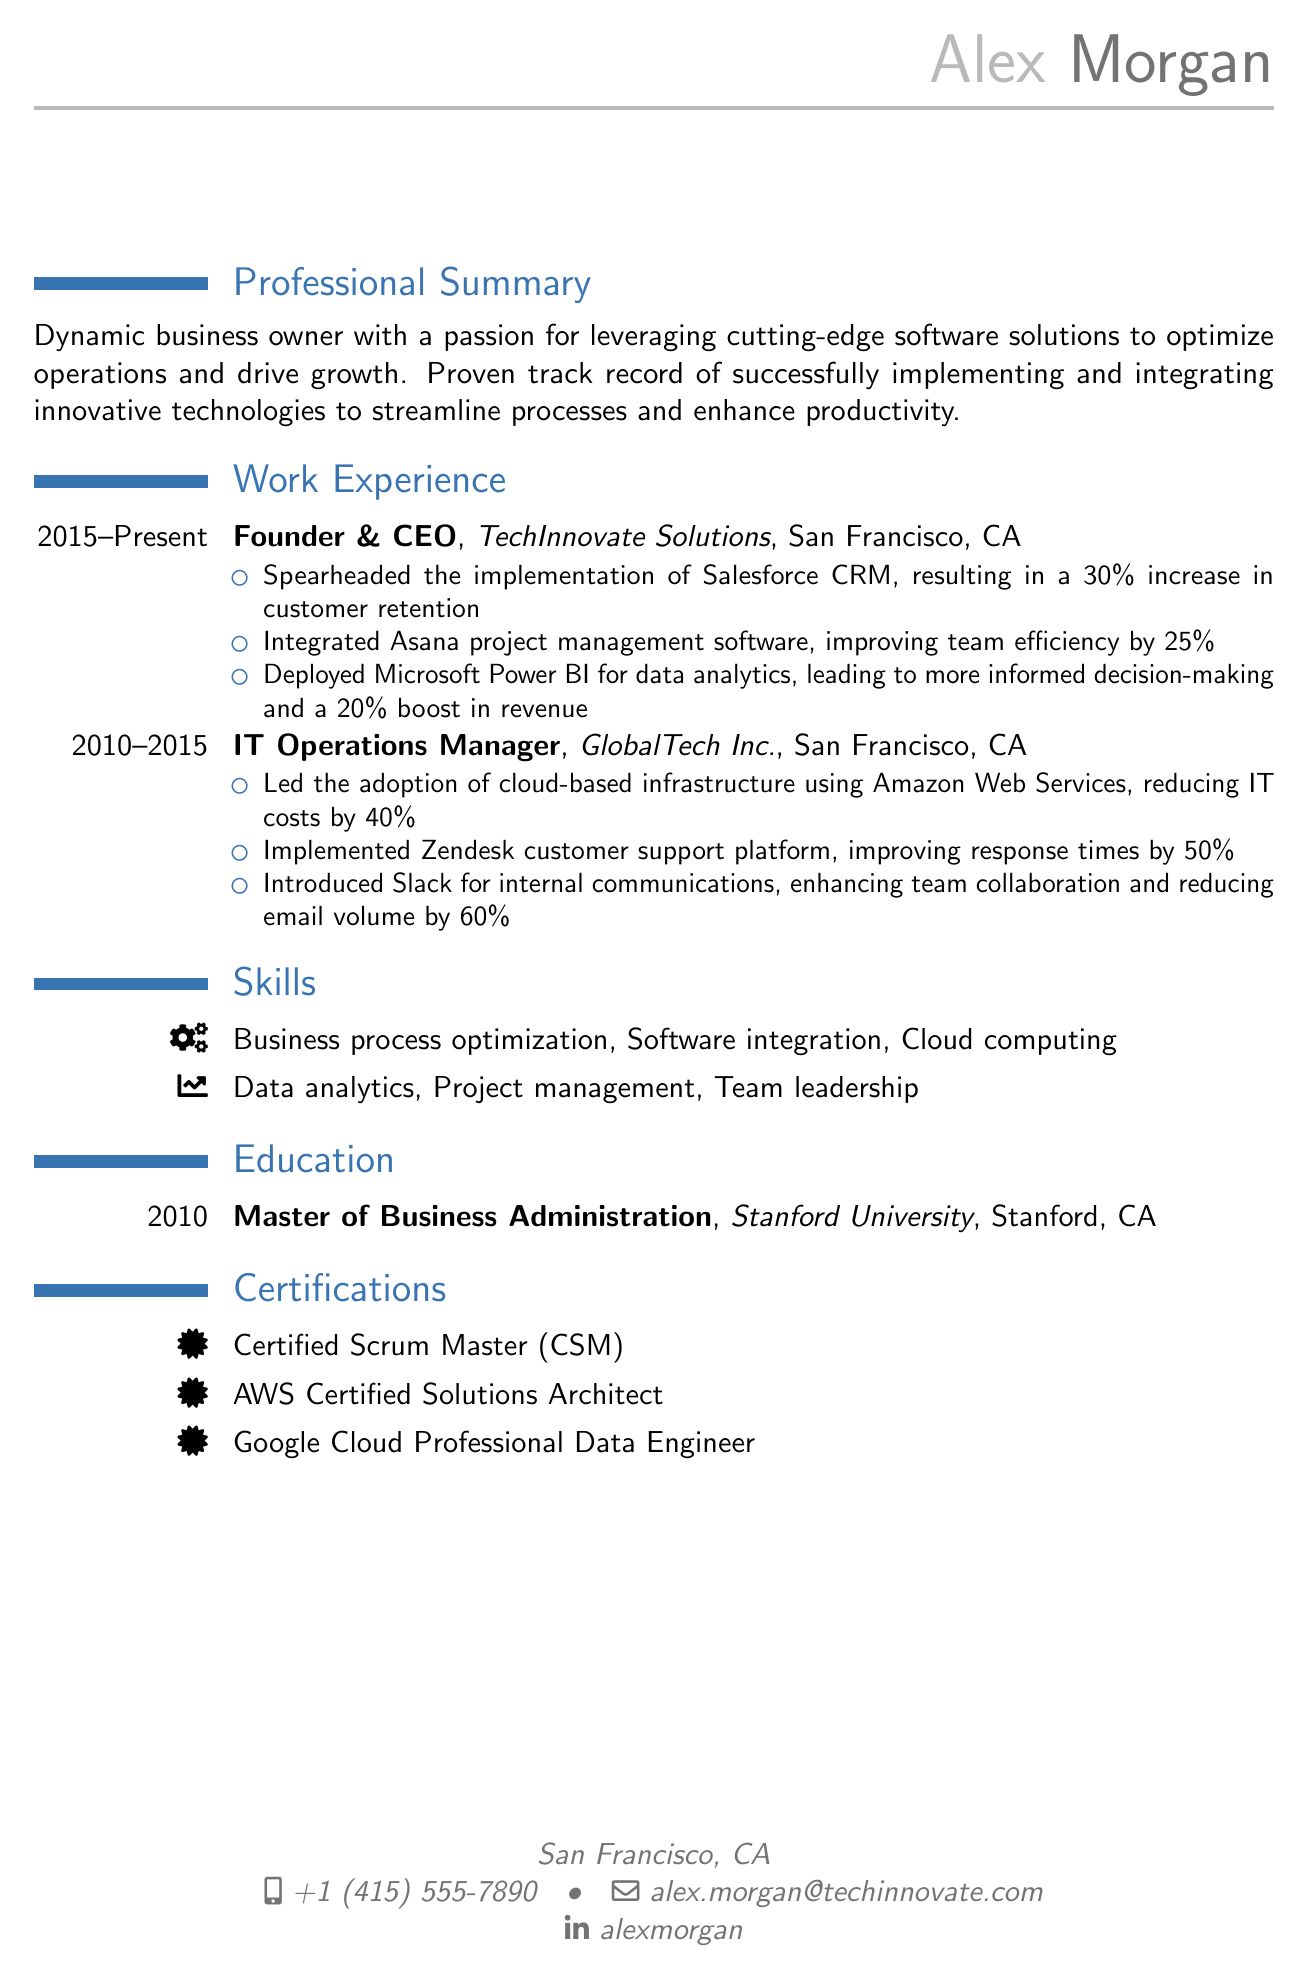what is the name of the business owner? The name of the business owner is mentioned in the personal information section of the document.
Answer: Alex Morgan what is the job title of Alex Morgan at TechInnovate Solutions? The job title is indicated in the work experience section under the first cventry.
Answer: Founder & CEO what percentage increase in customer retention was achieved with Salesforce CRM? The document states the specific improvement made through the software implementation.
Answer: 30% which software was integrated to improve team efficiency? The document lists the specific software solution implemented to enhance operational efficiency.
Answer: Asana how many certifications does Alex Morgan have? The number of certifications is indicated in the certifications section of the document.
Answer: 3 what was the IT cost reduction percentage achieved with AWS? The document specifies the outcome of the cloud infrastructure adoption in the responsibilities of the IT Operations Manager.
Answer: 40% which university did Alex Morgan attend for their MBA? The educational background section includes the institution name relevant to the degree earners.
Answer: Stanford University what impact did Microsoft Power BI have on revenue? The document quantifies the financial boost as a direct result of integrating data analytics software.
Answer: 20% how long did Alex Morgan work at GlobalTech Inc.? The duration of employment is mentioned in the work experience section for the specific job role.
Answer: 5 years 